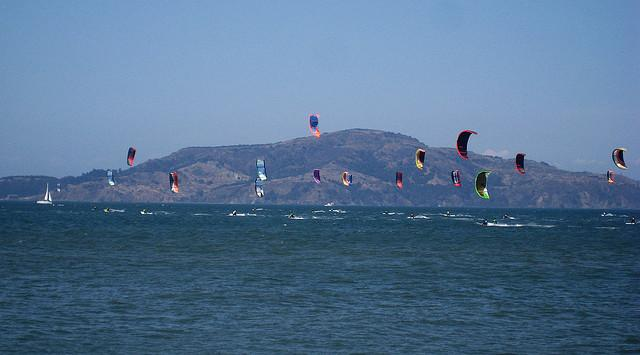Which direction does the wind blow? Please explain your reasoning. toward boat. The sail will blow towards the boats. 